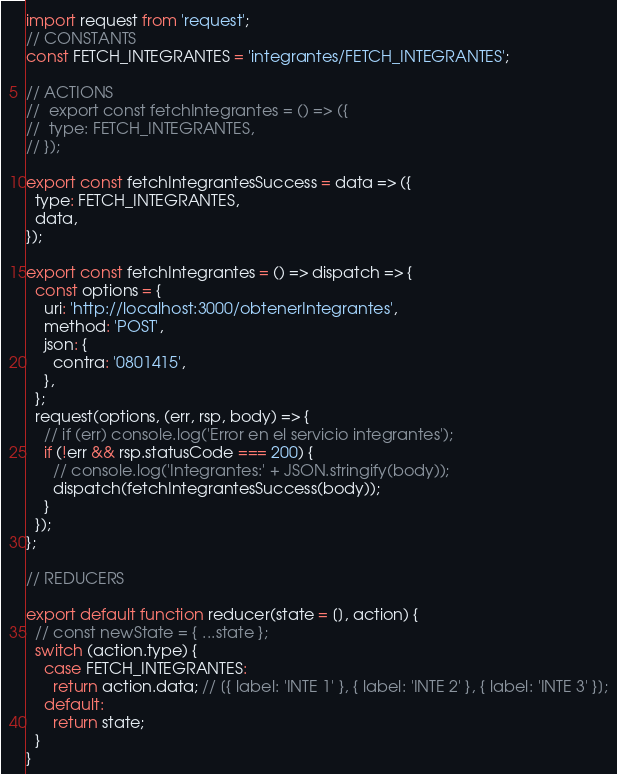Convert code to text. <code><loc_0><loc_0><loc_500><loc_500><_JavaScript_>import request from 'request';
// CONSTANTS
const FETCH_INTEGRANTES = 'integrantes/FETCH_INTEGRANTES';

// ACTIONS
//  export const fetchIntegrantes = () => ({
//  type: FETCH_INTEGRANTES,
// });

export const fetchIntegrantesSuccess = data => ({
  type: FETCH_INTEGRANTES,
  data,
});

export const fetchIntegrantes = () => dispatch => {
  const options = {
    uri: 'http://localhost:3000/obtenerIntegrantes',
    method: 'POST',
    json: {
      contra: '0801415',
    },
  };
  request(options, (err, rsp, body) => {
    // if (err) console.log('Error en el servicio integrantes');
    if (!err && rsp.statusCode === 200) {
      // console.log('Integrantes:' + JSON.stringify(body));
      dispatch(fetchIntegrantesSuccess(body));
    }
  });
};

// REDUCERS

export default function reducer(state = [], action) {
  // const newState = { ...state };
  switch (action.type) {
    case FETCH_INTEGRANTES:
      return action.data; // [{ label: 'INTE 1' }, { label: 'INTE 2' }, { label: 'INTE 3' }];
    default:
      return state;
  }
}
</code> 